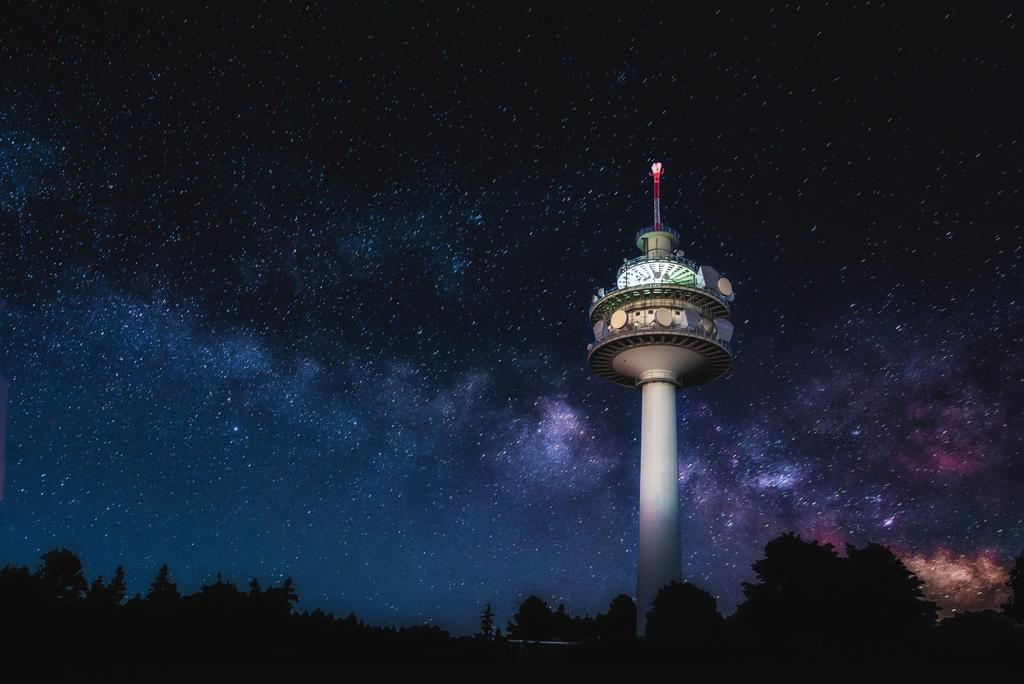What type of vegetation is present in the image? There are trees in the image. What structure can be seen in the image? There is a tower in the image. What part of the natural environment is visible in the image? The sky is visible in the background of the image. How would you describe the lighting in the image? The image appears to be in a dark setting. What type of horn is attached to the tree in the image? There is no horn attached to the tree in the image. How many sticks can be seen in the image? There are no sticks present in the image. 